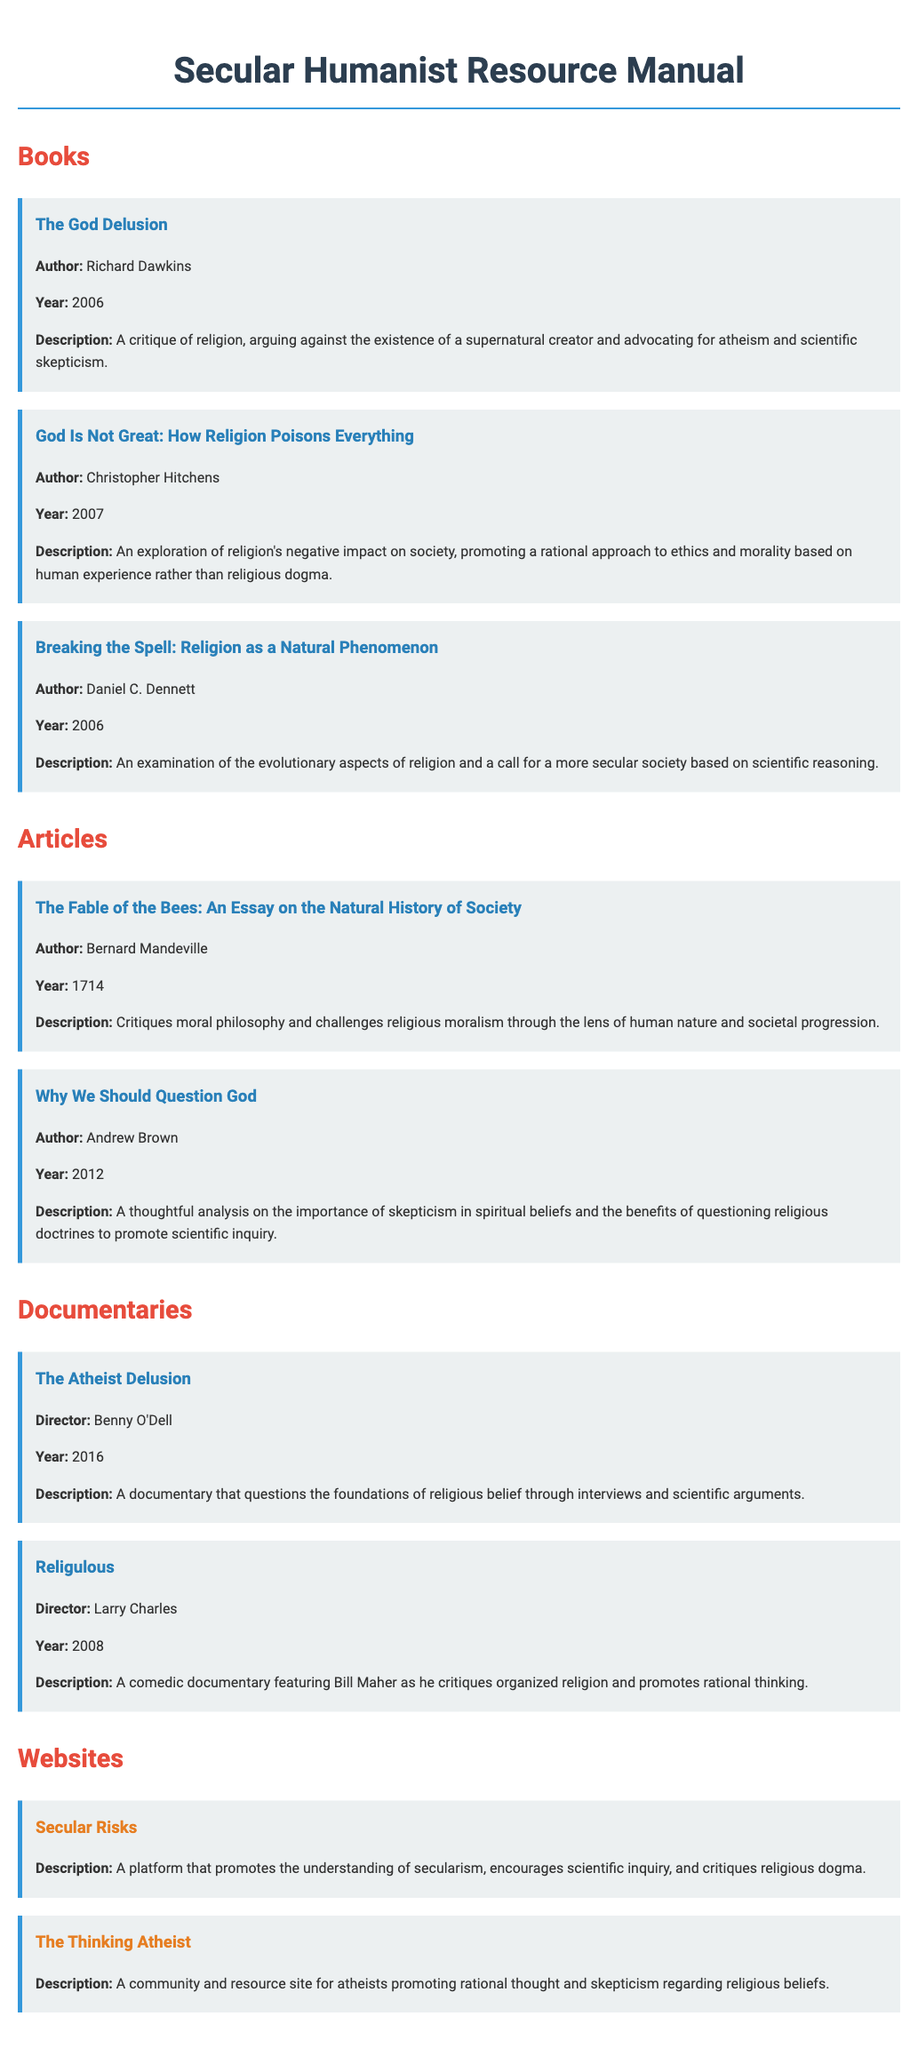What is the title of the book by Richard Dawkins? The title provided in the document is specifically mentioned as "The God Delusion."
Answer: The God Delusion Who directed the documentary "Religulous"? The document states that "Religulous" was directed by Larry Charles.
Answer: Larry Charles In what year was "God Is Not Great: How Religion Poisons Everything" published? The year of publication for "God Is Not Great: How Religion Poisons Everything" is explicitly noted as 2007 in the document.
Answer: 2007 What is the main topic of the article "Why We Should Question God"? The document describes the main topic of "Why We Should Question God" as the importance of skepticism in spiritual beliefs related to questioning religious doctrines.
Answer: Skepticism Which website is known for promoting the understanding of secularism? The document lists "Secular Risks" as a platform encouraging understanding of secularism.
Answer: Secular Risks What is the focus of the book "Breaking the Spell: Religion as a Natural Phenomenon"? The document indicates that the focus of "Breaking the Spell" is on the evolutionary aspects of religion.
Answer: Evolutionary aspects What common theme is shared by the books listed in the manual? The common theme among the listed books is their critique of religion and promotion of scientific skepticism.
Answer: Critique of religion What year was the article "The Fable of the Bees" written? The document provides that "The Fable of the Bees" was published in 1714.
Answer: 1714 